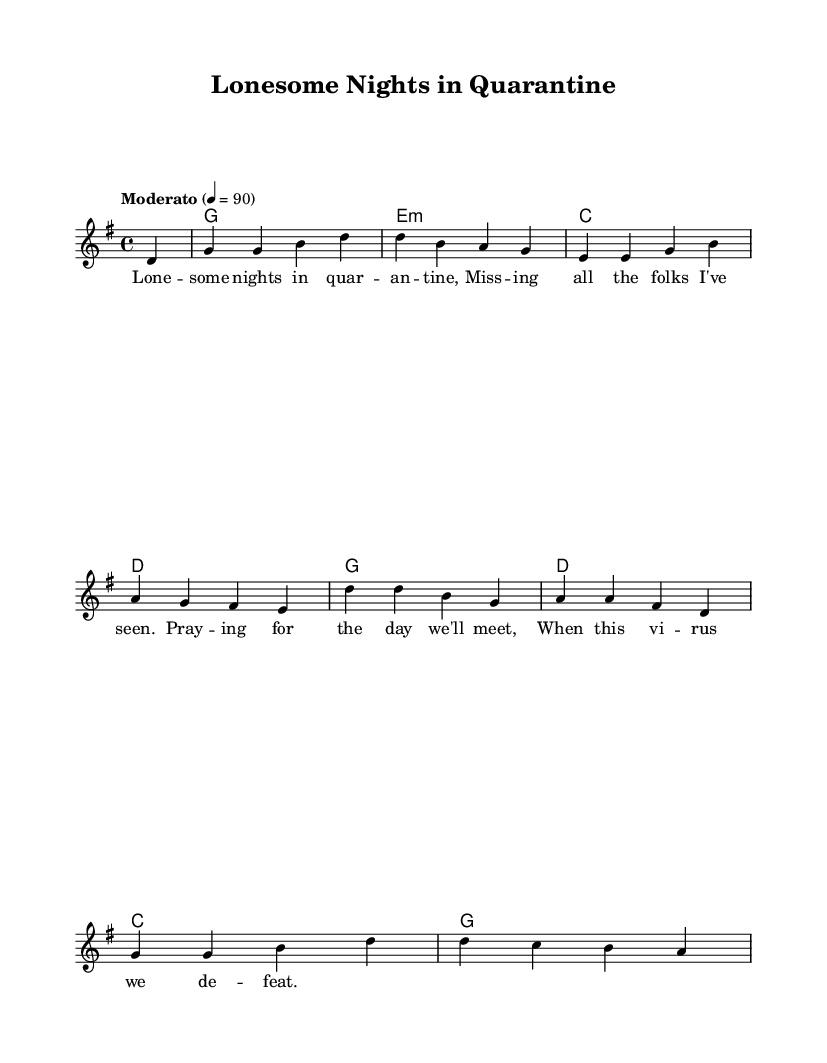What is the key signature of this music? The key signature is G major, which has one sharp (F#). This can be determined from the markings at the beginning of the music sheet that indicate which sharps are present.
Answer: G major What is the time signature of this piece? The time signature is 4/4, shown in the first part of the sheet music. This indicates that there are four beats in each measure and the quarter note gets one beat.
Answer: 4/4 What is the tempo marking indicated in the sheet music? The tempo marking is "Moderato" with a metronome marking of 4 = 90. This shows the expected speed of the piece. The text indicates a moderate pace, while the number specifies beats per minute.
Answer: Moderato, 4 = 90 How many measures are there in the piece? By counting the distinct groups of notes between bar lines, there are eight measures in total, each containing different rhythmic patterns or chords.
Answer: 8 What is the main theme expressed in the lyrics? The lyrics convey feelings of loneliness and longing during quarantined nights. This emotional content is often found in folk-country songs, reflecting personal experiences and struggles related to isolation.
Answer: Loneliness and longing Which chord is played in the first measure? The first measure contains a G major chord, which is represented by the symbol for the chord below the notes. Chords are typically labeled on a separate line and indicate which notes should be harmonized along with the melody.
Answer: G What genre does this song represent? The song represents a Folk-country fusion genre, which is characterized by blending traditional folk elements with country music themes. The lyrical content and musical style align with this classification.
Answer: Folk-country fusion 